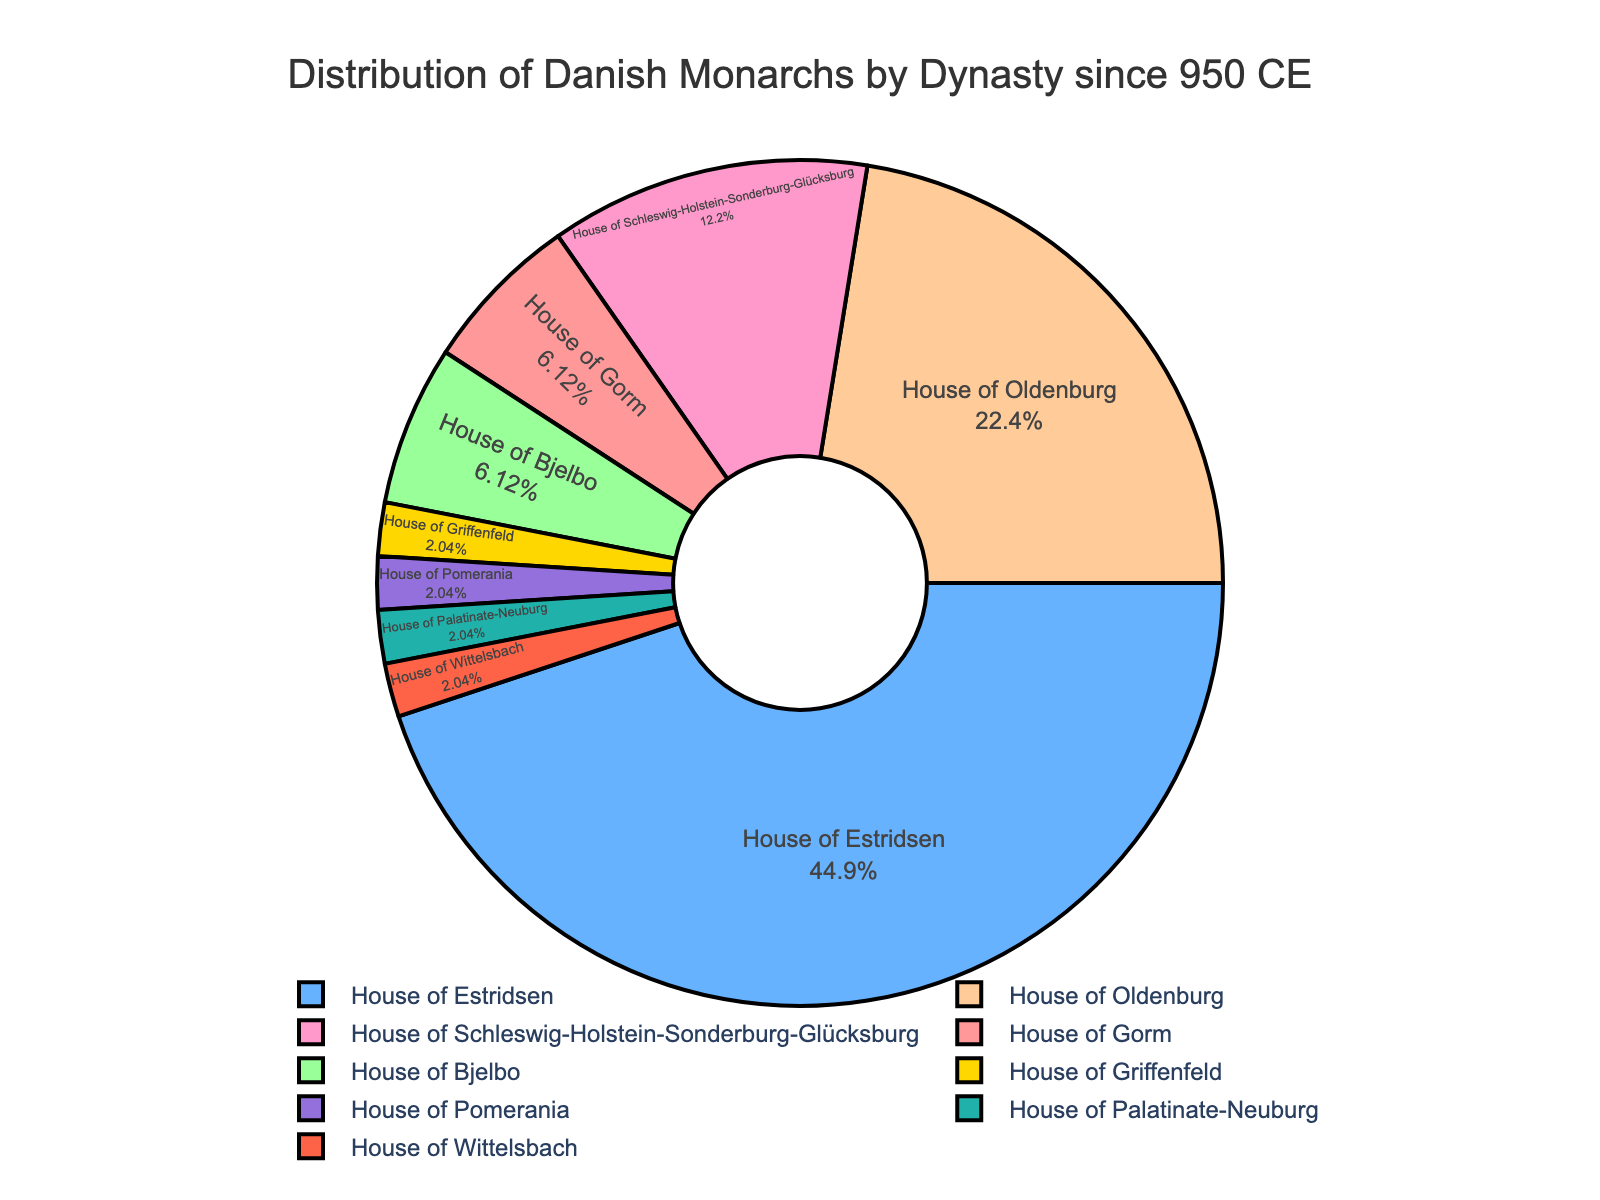What percentage of Danish monarchs came from the House of Estridsen? The figure shows that the House of Estridsen is one of the segments of the pie chart. Reading from the figure, the House of Estridsen comprises 22 monarchs. Calculate the percentage by dividing 22 by the total number of monarchs (48) and multiplying by 100.
Answer: 45.8% How many more monarchs come from the House of Oldenburg compared to the House of Gorm? According to the figure, the House of Oldenburg has 11 monarchs, and the House of Gorm has 3 monarchs. Subtract the number of monarchs of the House of Gorm from the House of Oldenburg: 11 - 3.
Answer: 8 Which dynasty has the smallest representation in terms of monarchs? The pie chart shows several dynasties, some with only one monarch. The House of Griffenfeld, House of Pomerania, House of Palatinate-Neuburg, and House of Wittelsbach each have only 1 monarch.
Answer: House of Griffenfeld, House of Pomerania, House of Palatinate-Neuburg, House of Wittelsbach What is the combined percentage of monarchs from the dynasties with only one monarch each? The figure provides the dynasties with one monarch each (House of Griffenfeld, Pomerania, Palatinate-Neuburg, Wittelsbach). Calculate their combined percentage by (1/48) * 100 for each and summing them up: (1/48 * 4) * 100.
Answer: 8.3% Are there more monarchs from the House of Gorm or the House of Bjelbo? The figure shows that both the House of Gorm and the House of Bjelbo have the same number of monarchs.
Answer: No, they are equal What proportion of monarchs come from the House of Oldenburg compared to the total? From the pie chart, the House of Oldenburg has 11 monarchs. To find the proportion, divide the number of monarchs of the House of Oldenburg by the total number of monarchs (48): 11/48.
Answer: 22.9% How many monarchs came from dynasties other than the House of Estridsen and House of Oldenburg? The figure shows the House of Estridsen with 22 monarchs and the House of Oldenburg with 11 monarchs. Subtract the sum of these two from the total number of monarchs (48): 48 - (22 + 11).
Answer: 15 monarchs Which dynasty's segment is colored red in the pie chart? The figure visually uses colors to represent different dynasties, and we know that the first color in the list is typically red, often used for the first dynasty (House of Gorm). Confirm by examining the color representation.
Answer: House of Gorm What percentage of Danish monarchs come from the House of Gorm? The pie chart indicates that the House of Gorm has 3 monarchs. Calculate the percentage by dividing 3 by the total number of monarchs (48) and multiplying by 100.
Answer: 6.3% 